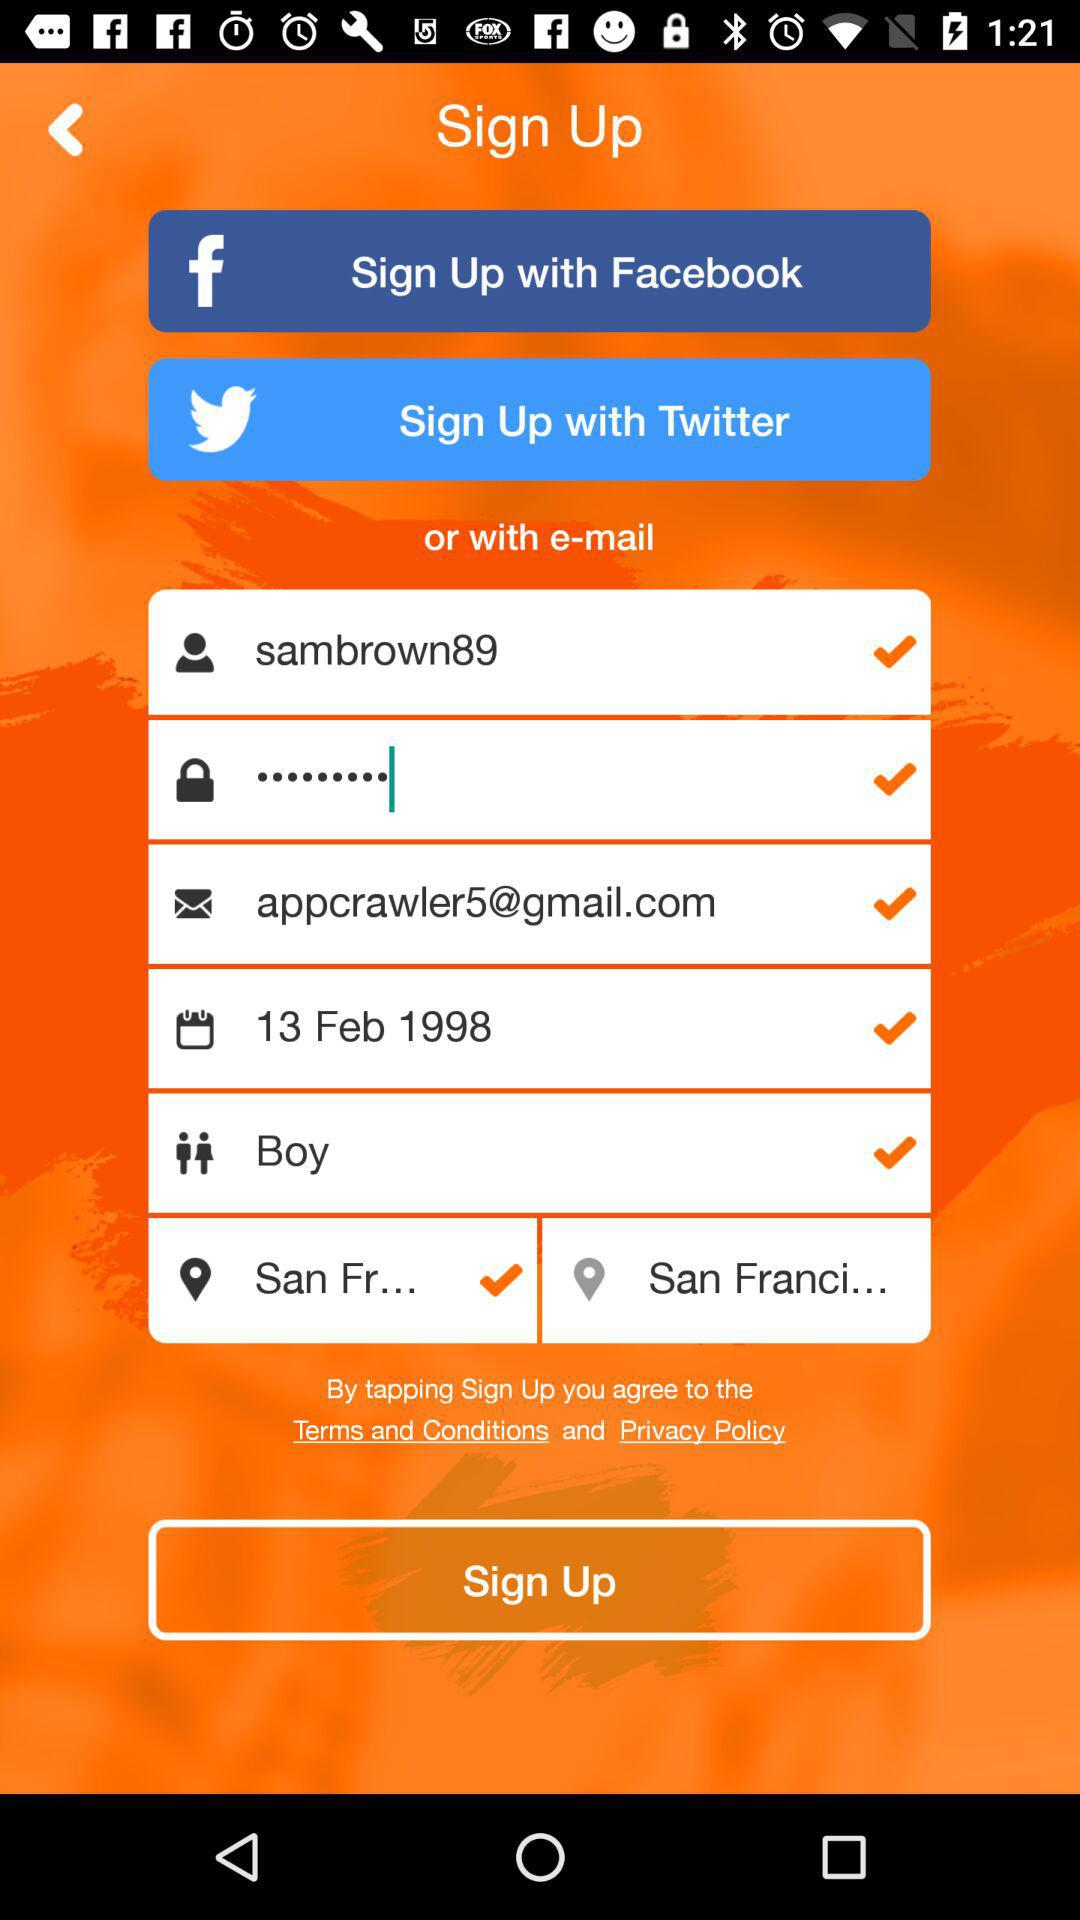What is the username? The username is "sambrown89". 